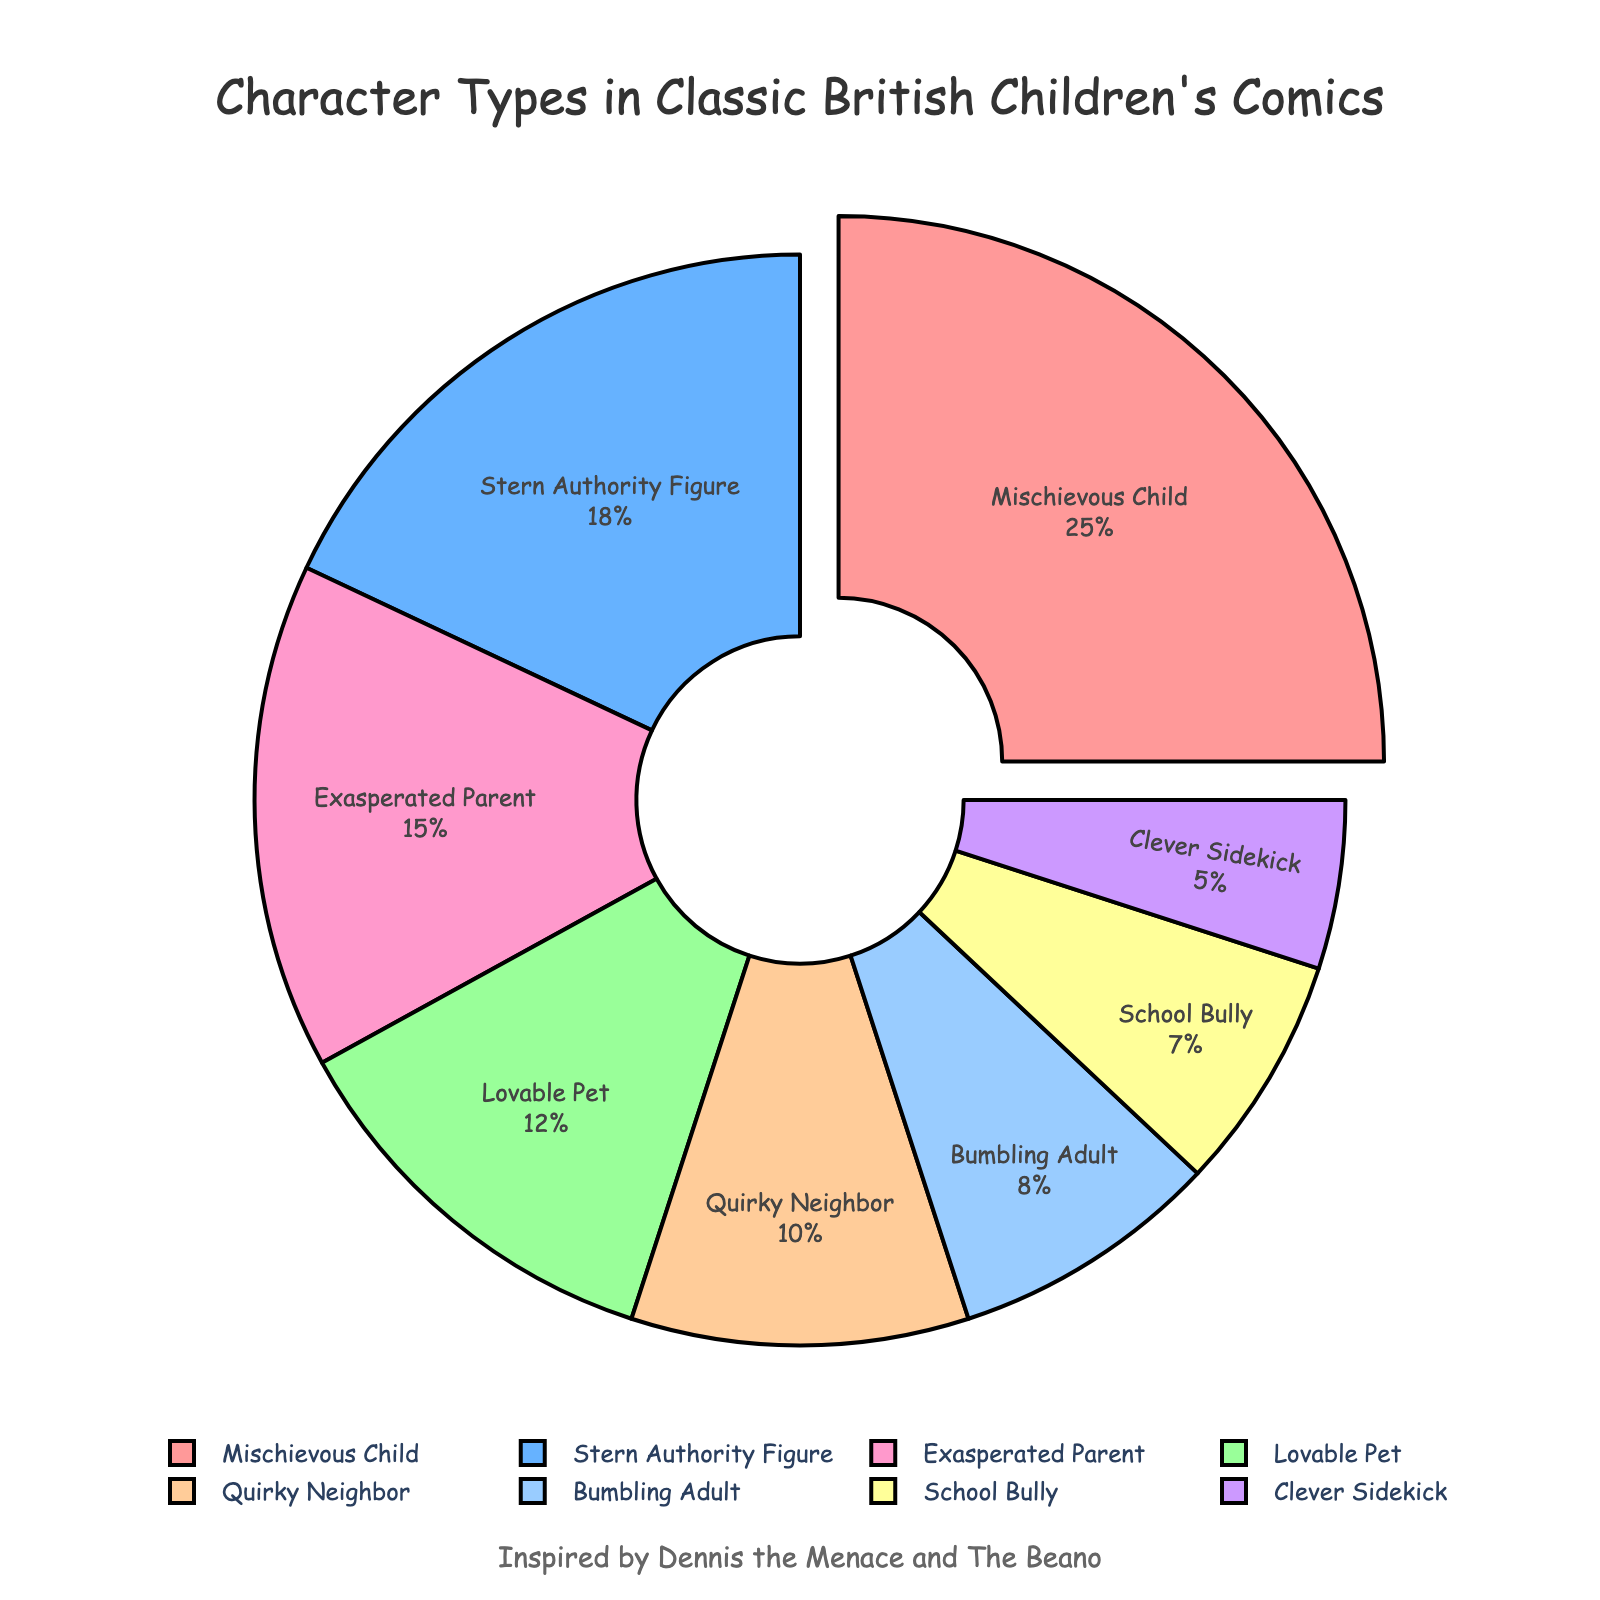what percentage of characters are either Exasperated Parents or School Bullies? Combine the percentages for Exasperated Parent (15) and School Bully (7). The total is 15 + 7 = 22%
Answer: 22% Which character type has the smallest slice in the pie chart? The Clever Sidekick has the smallest percentage, which is 5%
Answer: Clever Sidekick Is the percentage of Mischievous Child characters higher than that of Stern Authority Figures? The percentage for Mischievous Child is 25%, while for Stern Authority Figures, it is 18%. Since 25% is greater than 18%, the answer is yes
Answer: Yes What is the ratio of Lovable Pets to Bumbling Adults? The percentage for Lovable Pet is 12%, and for Bumbling Adult, it is 8%. The ratio is 12:8, which simplifies to 3:2
Answer: 3:2 Are Exasperated Parents more common than Quirky Neighbors? The percentage for Exasperated Parents is 15%, and for Quirky Neighbors, it is 10%. Since 15% is greater than 10%, the answer is yes
Answer: Yes What is the total percentage of characters that are either Bumbling Adults or School Bullies? The percentage for Bumbling Adults is 8%, and for School Bullies, it is 7%. The total is 8 + 7 = 15%
Answer: 15% Which character type has the most considerable pull-out in the pie chart? The character type with the most pull-out is the Mischievous Child since it is pulled out the most prominently
Answer: Mischievous Child Which color is used for the Stern Authority Figure slice? The Stern Authority Figure slice is colored in blue based on the color scheme provided
Answer: Blue Is the sum of the percentages for Quirky Neighbor and Clever Sidekick greater than the percentage for Lovable Pet? The combined percentage for Quirky Neighbor (10%) and Clever Sidekick (5%) is 10 + 5 = 15%. Since 15% is greater than the percentage for Lovable Pet, which is 12%, the answer is yes
Answer: Yes What percentage of the characters are not Mischievous Children? The percentage of Mischievous Child characters is 25%. To find the percentage that is not Mischievous Children, subtract this from 100%, which is 100 - 25 = 75%
Answer: 75% 